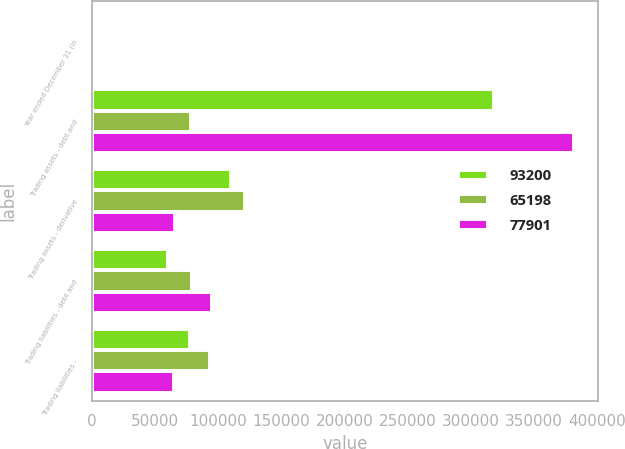<chart> <loc_0><loc_0><loc_500><loc_500><stacked_bar_chart><ecel><fcel>Year ended December 31 (in<fcel>Trading assets - debt and<fcel>Trading assets - derivative<fcel>Trading liabilities - debt and<fcel>Trading liabilities -<nl><fcel>93200<fcel>2009<fcel>318063<fcel>110457<fcel>60224<fcel>77901<nl><fcel>65198<fcel>2008<fcel>78371<fcel>121417<fcel>78841<fcel>93200<nl><fcel>77901<fcel>2007<fcel>381415<fcel>65439<fcel>94737<fcel>65198<nl></chart> 